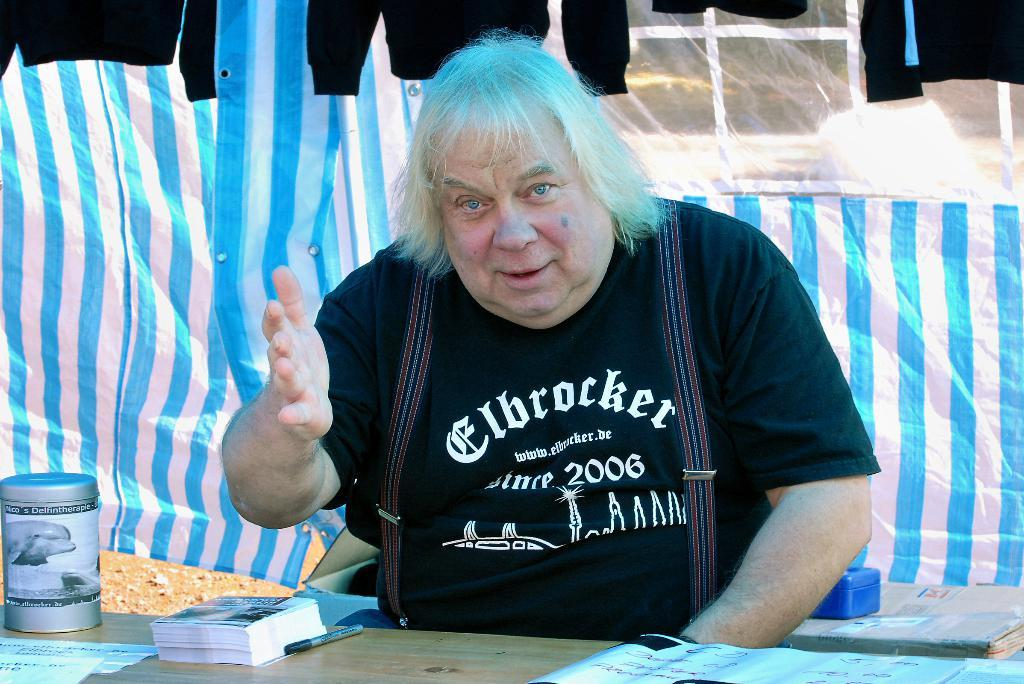What is the person in the image doing? There is a person sitting in the image. What is located near the person in the image? There is a table in the image. What items can be seen on the table? There are pamphlets and a pen on the table. What can be seen hanging in the background of the image? There are jackets hanging in the background of the image. What type of cheese is being served on the table in the image? There is no cheese present in the image; the table has pamphlets and a pen on it. 